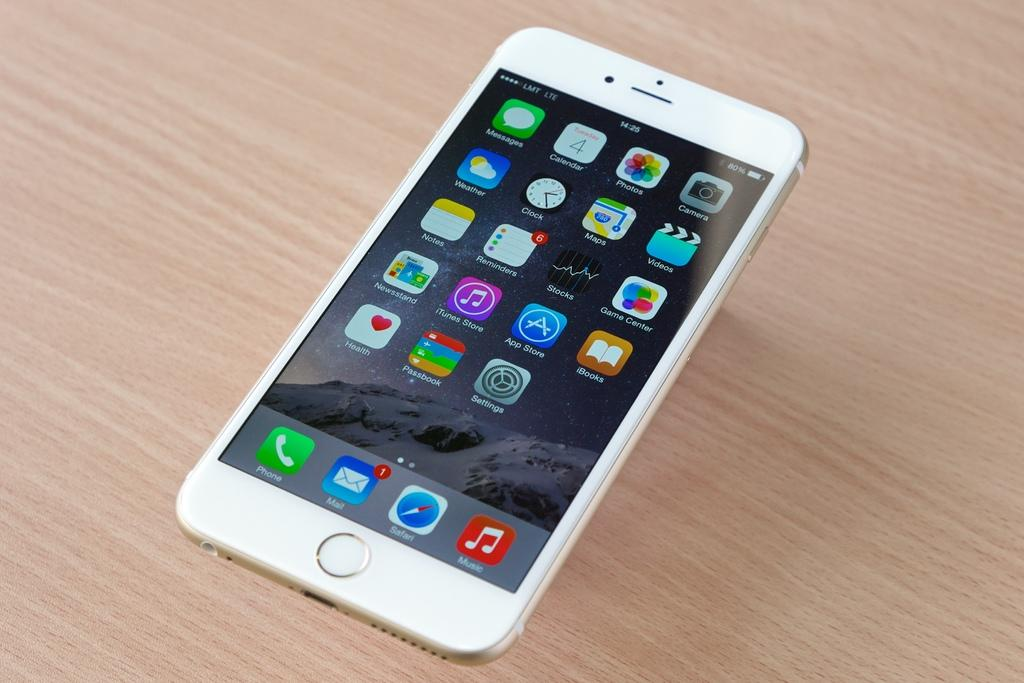<image>
Give a short and clear explanation of the subsequent image. a phone that has the word mail on it 